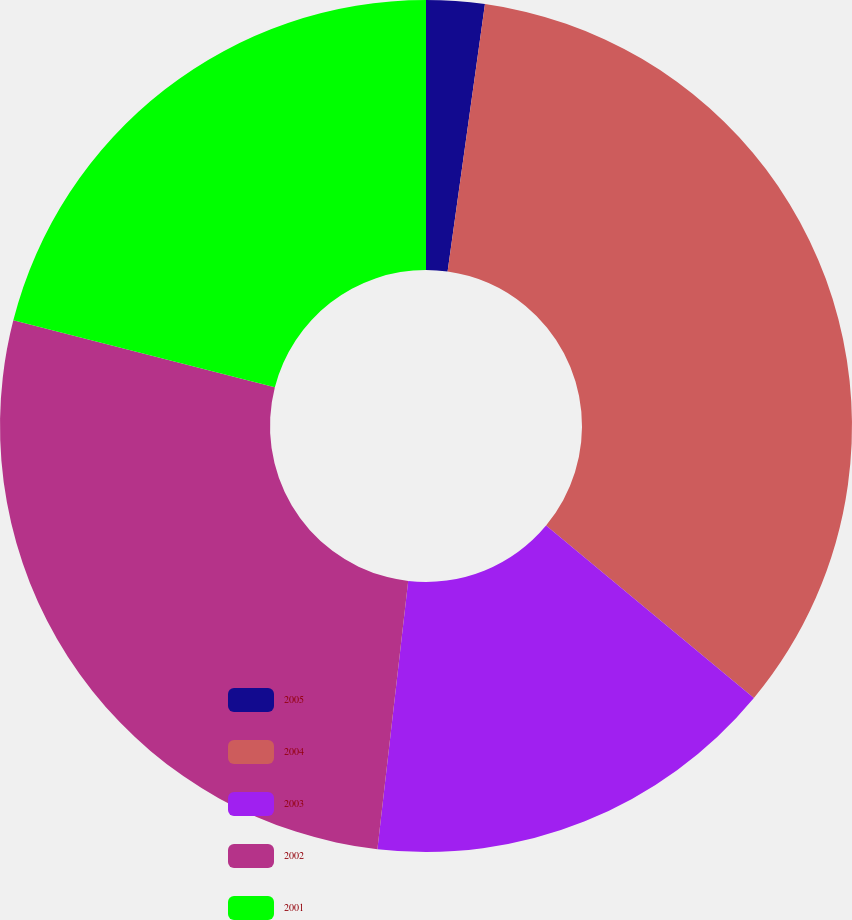Convert chart to OTSL. <chart><loc_0><loc_0><loc_500><loc_500><pie_chart><fcel>2005<fcel>2004<fcel>2003<fcel>2002<fcel>2001<nl><fcel>2.21%<fcel>33.81%<fcel>15.8%<fcel>27.17%<fcel>21.01%<nl></chart> 